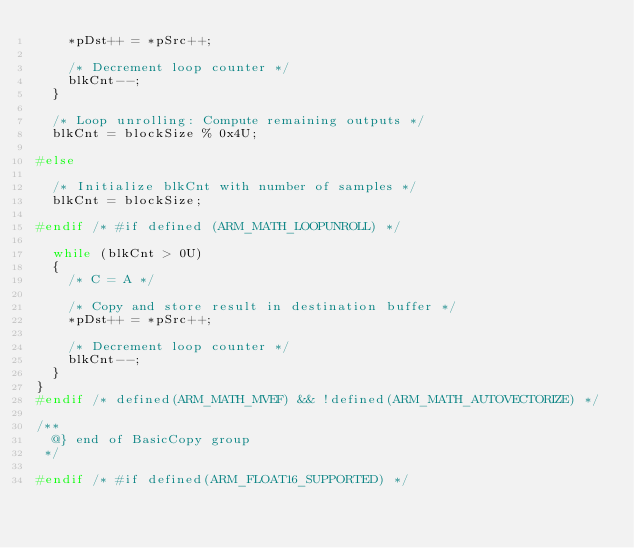Convert code to text. <code><loc_0><loc_0><loc_500><loc_500><_C_>    *pDst++ = *pSrc++;

    /* Decrement loop counter */
    blkCnt--;
  }

  /* Loop unrolling: Compute remaining outputs */
  blkCnt = blockSize % 0x4U;

#else

  /* Initialize blkCnt with number of samples */
  blkCnt = blockSize;

#endif /* #if defined (ARM_MATH_LOOPUNROLL) */

  while (blkCnt > 0U)
  {
    /* C = A */

    /* Copy and store result in destination buffer */
    *pDst++ = *pSrc++;

    /* Decrement loop counter */
    blkCnt--;
  }
}
#endif /* defined(ARM_MATH_MVEF) && !defined(ARM_MATH_AUTOVECTORIZE) */

/**
  @} end of BasicCopy group
 */

#endif /* #if defined(ARM_FLOAT16_SUPPORTED) */ 

</code> 